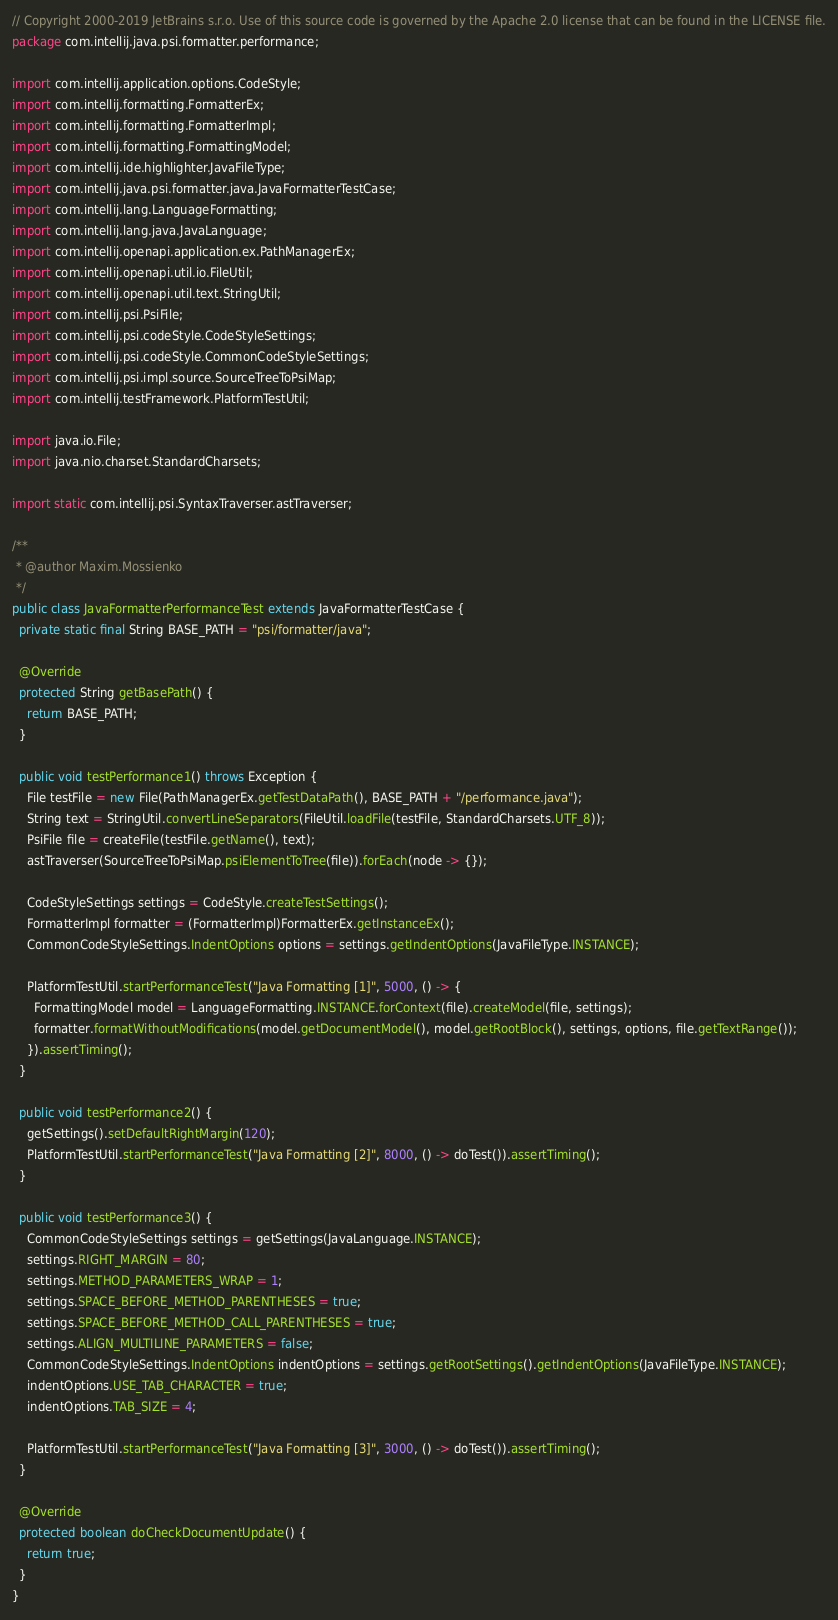<code> <loc_0><loc_0><loc_500><loc_500><_Java_>// Copyright 2000-2019 JetBrains s.r.o. Use of this source code is governed by the Apache 2.0 license that can be found in the LICENSE file.
package com.intellij.java.psi.formatter.performance;

import com.intellij.application.options.CodeStyle;
import com.intellij.formatting.FormatterEx;
import com.intellij.formatting.FormatterImpl;
import com.intellij.formatting.FormattingModel;
import com.intellij.ide.highlighter.JavaFileType;
import com.intellij.java.psi.formatter.java.JavaFormatterTestCase;
import com.intellij.lang.LanguageFormatting;
import com.intellij.lang.java.JavaLanguage;
import com.intellij.openapi.application.ex.PathManagerEx;
import com.intellij.openapi.util.io.FileUtil;
import com.intellij.openapi.util.text.StringUtil;
import com.intellij.psi.PsiFile;
import com.intellij.psi.codeStyle.CodeStyleSettings;
import com.intellij.psi.codeStyle.CommonCodeStyleSettings;
import com.intellij.psi.impl.source.SourceTreeToPsiMap;
import com.intellij.testFramework.PlatformTestUtil;

import java.io.File;
import java.nio.charset.StandardCharsets;

import static com.intellij.psi.SyntaxTraverser.astTraverser;

/**
 * @author Maxim.Mossienko
 */
public class JavaFormatterPerformanceTest extends JavaFormatterTestCase {
  private static final String BASE_PATH = "psi/formatter/java";

  @Override
  protected String getBasePath() {
    return BASE_PATH;
  }

  public void testPerformance1() throws Exception {
    File testFile = new File(PathManagerEx.getTestDataPath(), BASE_PATH + "/performance.java");
    String text = StringUtil.convertLineSeparators(FileUtil.loadFile(testFile, StandardCharsets.UTF_8));
    PsiFile file = createFile(testFile.getName(), text);
    astTraverser(SourceTreeToPsiMap.psiElementToTree(file)).forEach(node -> {});

    CodeStyleSettings settings = CodeStyle.createTestSettings();
    FormatterImpl formatter = (FormatterImpl)FormatterEx.getInstanceEx();
    CommonCodeStyleSettings.IndentOptions options = settings.getIndentOptions(JavaFileType.INSTANCE);

    PlatformTestUtil.startPerformanceTest("Java Formatting [1]", 5000, () -> {
      FormattingModel model = LanguageFormatting.INSTANCE.forContext(file).createModel(file, settings);
      formatter.formatWithoutModifications(model.getDocumentModel(), model.getRootBlock(), settings, options, file.getTextRange());
    }).assertTiming();
  }

  public void testPerformance2() {
    getSettings().setDefaultRightMargin(120);
    PlatformTestUtil.startPerformanceTest("Java Formatting [2]", 8000, () -> doTest()).assertTiming();
  }

  public void testPerformance3() {
    CommonCodeStyleSettings settings = getSettings(JavaLanguage.INSTANCE);
    settings.RIGHT_MARGIN = 80;
    settings.METHOD_PARAMETERS_WRAP = 1;
    settings.SPACE_BEFORE_METHOD_PARENTHESES = true;
    settings.SPACE_BEFORE_METHOD_CALL_PARENTHESES = true;
    settings.ALIGN_MULTILINE_PARAMETERS = false;
    CommonCodeStyleSettings.IndentOptions indentOptions = settings.getRootSettings().getIndentOptions(JavaFileType.INSTANCE);
    indentOptions.USE_TAB_CHARACTER = true;
    indentOptions.TAB_SIZE = 4;

    PlatformTestUtil.startPerformanceTest("Java Formatting [3]", 3000, () -> doTest()).assertTiming();
  }

  @Override
  protected boolean doCheckDocumentUpdate() {
    return true;
  }
}</code> 